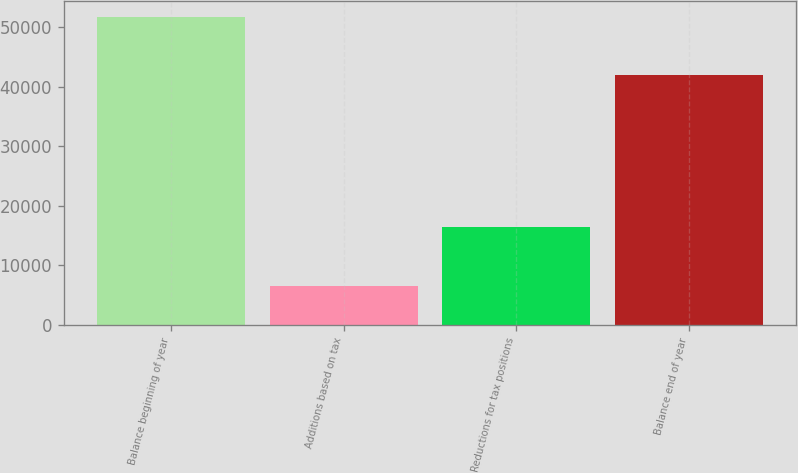<chart> <loc_0><loc_0><loc_500><loc_500><bar_chart><fcel>Balance beginning of year<fcel>Additions based on tax<fcel>Reductions for tax positions<fcel>Balance end of year<nl><fcel>51770<fcel>6528<fcel>16375<fcel>41923<nl></chart> 